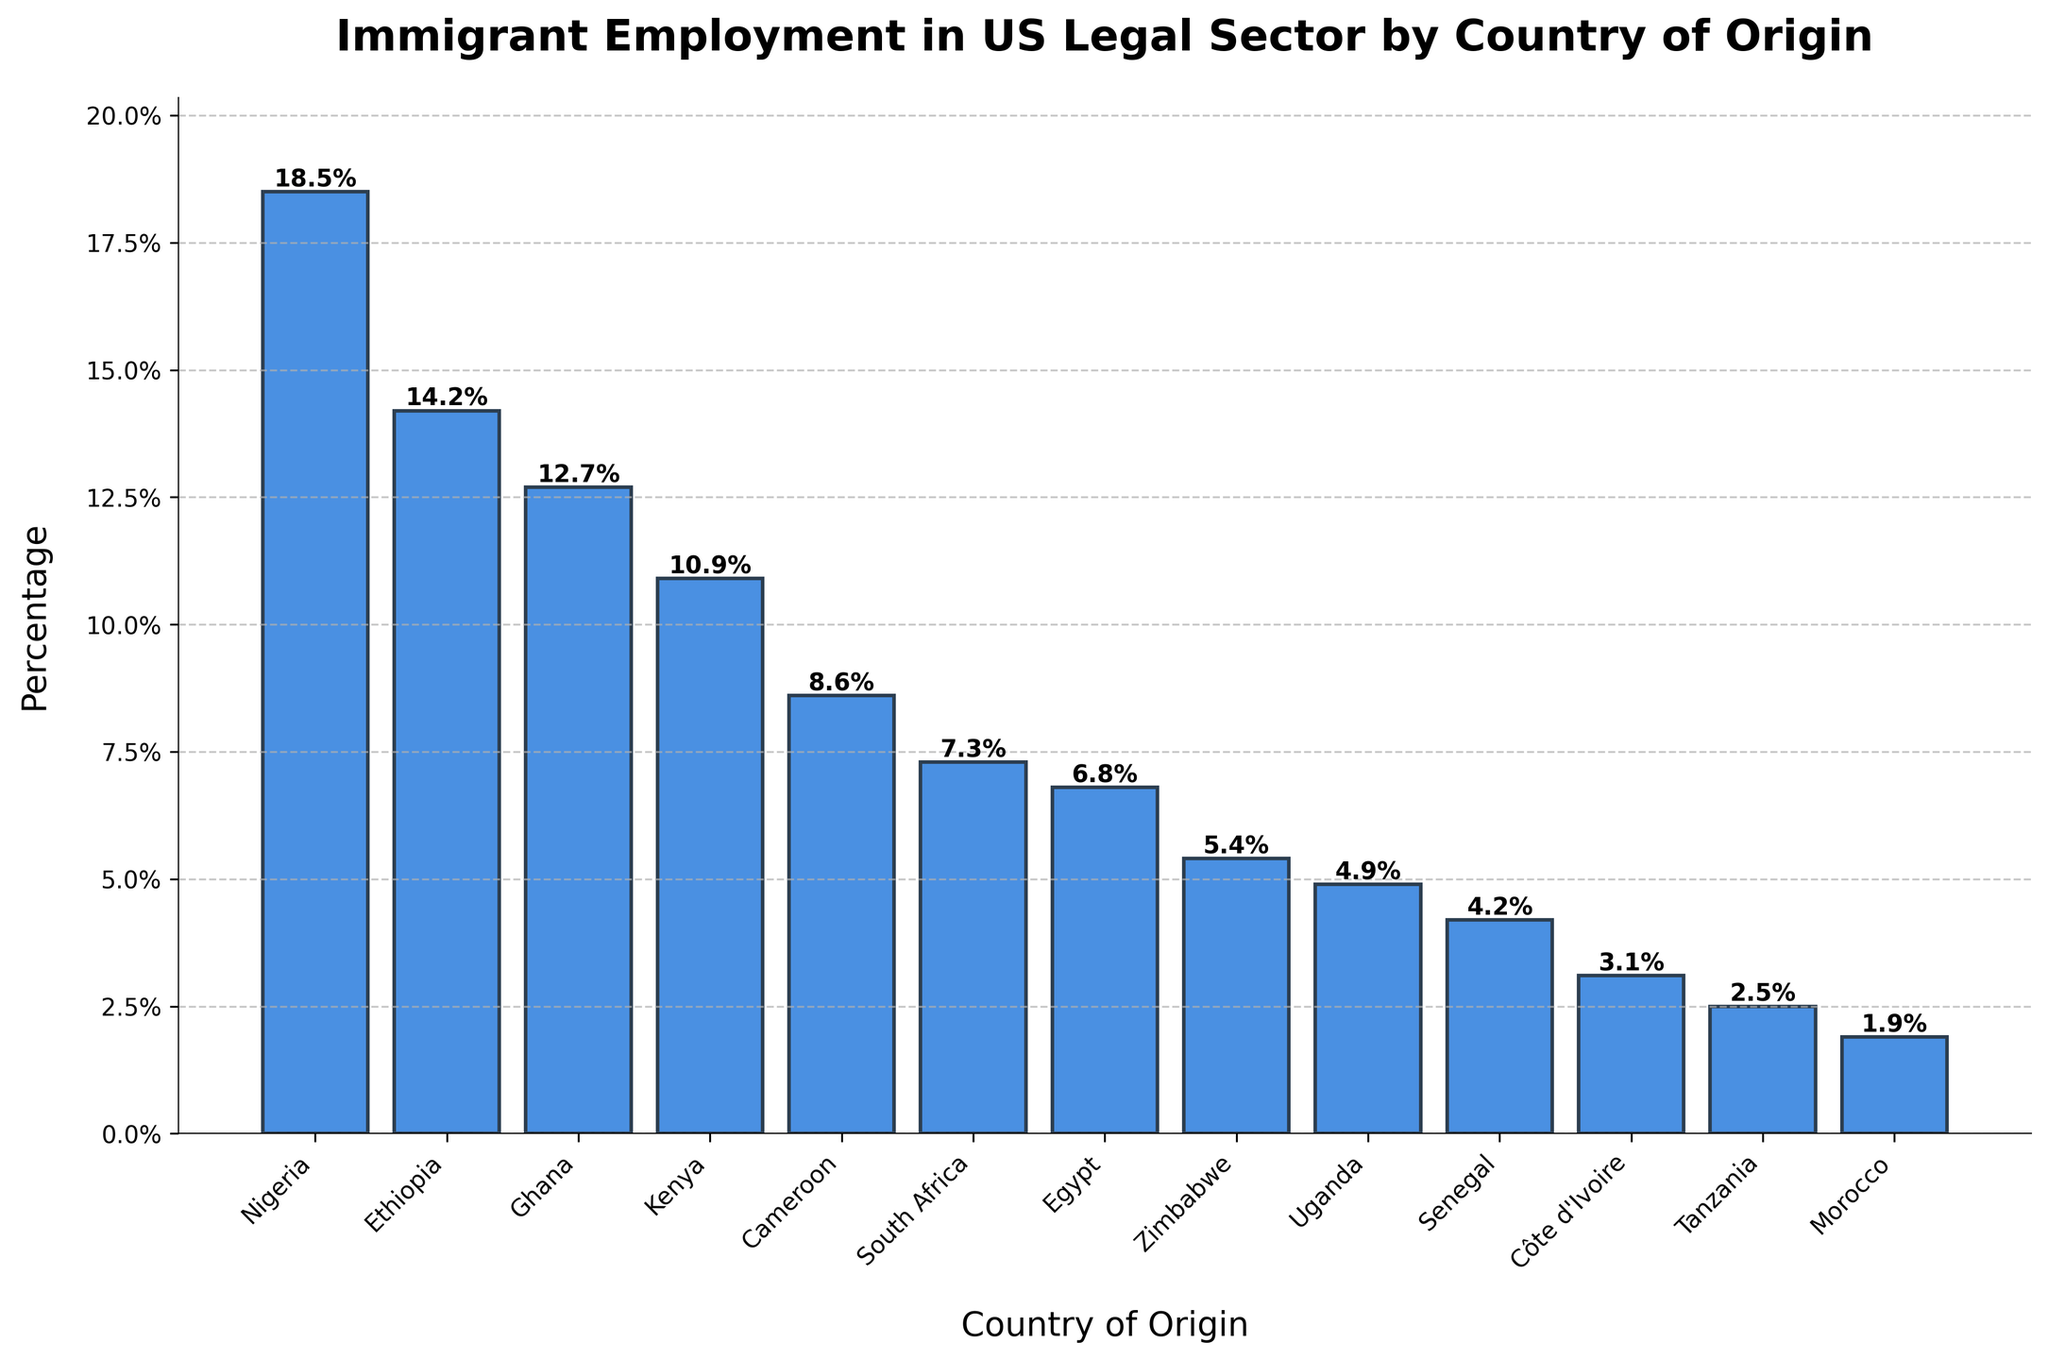What's the country with the highest percentage of immigrant employment in the US legal sector? The figure shows bars representing different countries, with the height indicating the percentage values. The tallest bar is for Nigeria, reaching 18.5%.
Answer: Nigeria What is the combined percentage of immigrants from Ethiopia, Ghana, and Kenya in the US legal sector? First, note the percentages for Ethiopia (14.2%), Ghana (12.7%), and Kenya (10.9%). Sum these values: 14.2 + 12.7 + 10.9 = 37.8%.
Answer: 37.8% Which country has a lower percentage, Zimbabwe or Uganda? Compare the heights of the bars for Zimbabwe and Uganda. Zimbabwe has 5.4% and Uganda has 4.9%.
Answer: Uganda What is the difference in percentage between the country with the highest and lowest immigrant employment in the US legal sector? Nigeria has the highest percentage (18.5%) and Morocco has the lowest (1.9%). Subtract 1.9 from 18.5 to find the difference: 18.5 - 1.9 = 16.6%.
Answer: 16.6% How many countries have a percentage value above 10%? Count the bars higher than 10%. They represent Nigeria (18.5%), Ethiopia (14.2%), Ghana (12.7%), and Kenya (10.9%).
Answer: 4 Which countries have percentages below 5%? Identify the bars shorter than 5%. They are Uganda (4.9%), Senegal (4.2%), Côte d'Ivoire (3.1%), Tanzania (2.5%), and Morocco (1.9%).
Answer: Uganda, Senegal, Côte d'Ivoire, Tanzania, Morocco What is the average percentage of immigrant employment for the top five countries? Identify the top five countries: Nigeria (18.5%), Ethiopia (14.2%), Ghana (12.7%), Kenya (10.9%), and Cameroon (8.6%). Calculate the average: (18.5 + 14.2 + 12.7 + 10.9 + 8.6) / 5 = 64.9 / 5 = 12.98%.
Answer: 12.98% What is the median percentage value of the plotted countries? Arrange the percentages in ascending order: 1.9%, 2.5%, 3.1%, 4.2%, 4.9%, 5.4%, 6.8%, 7.3%, 8.6%, 10.9%, 12.7%, 14.2%, 18.5%. The median is the middle value, 6.8%.
Answer: 6.8% Which country has a percentage closest to the average of the top three countries? Calculate the average for the top three countries: Nigeria (18.5%), Ethiopia (14.2%), and Ghana (12.7%). (18.5 + 14.2 + 12.7) / 3 = 45.4 / 3 = 15.13%. The country closest to 15.13% is Ethiopia with 14.2%.
Answer: Ethiopia 